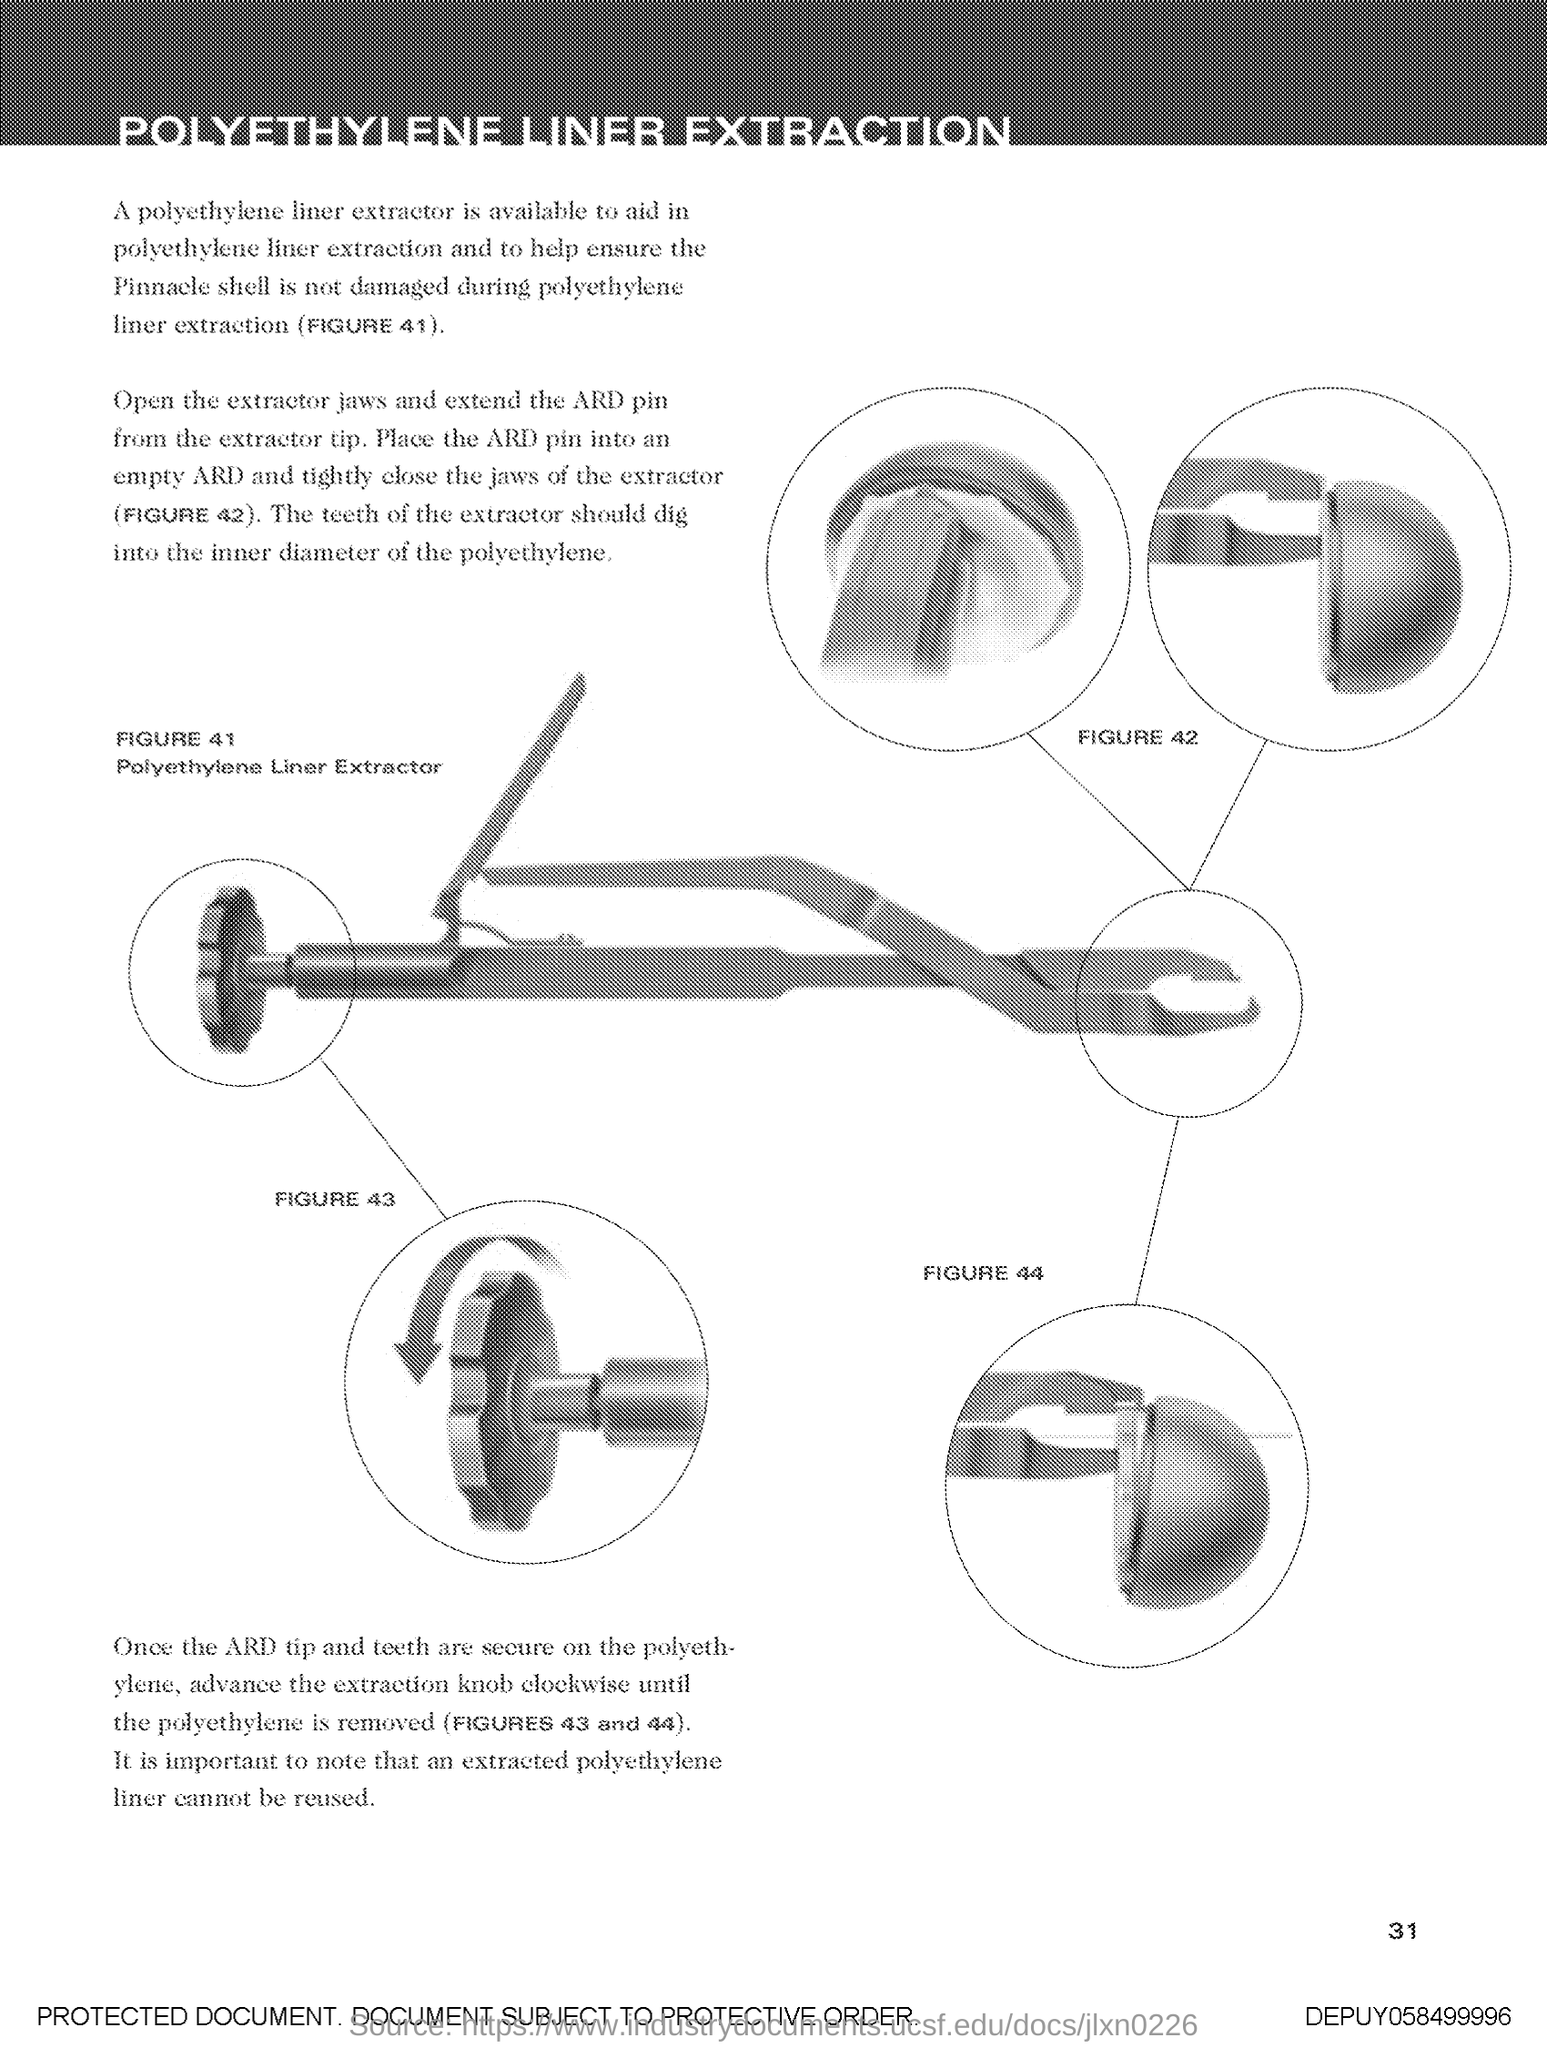What does FIGURE 41 in this document shows?
Your response must be concise. Polyethylene Liner Extractor. 